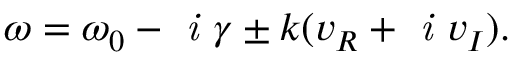<formula> <loc_0><loc_0><loc_500><loc_500>\omega = \omega _ { 0 } - i \gamma \pm k ( v _ { R } + i v _ { I } ) .</formula> 